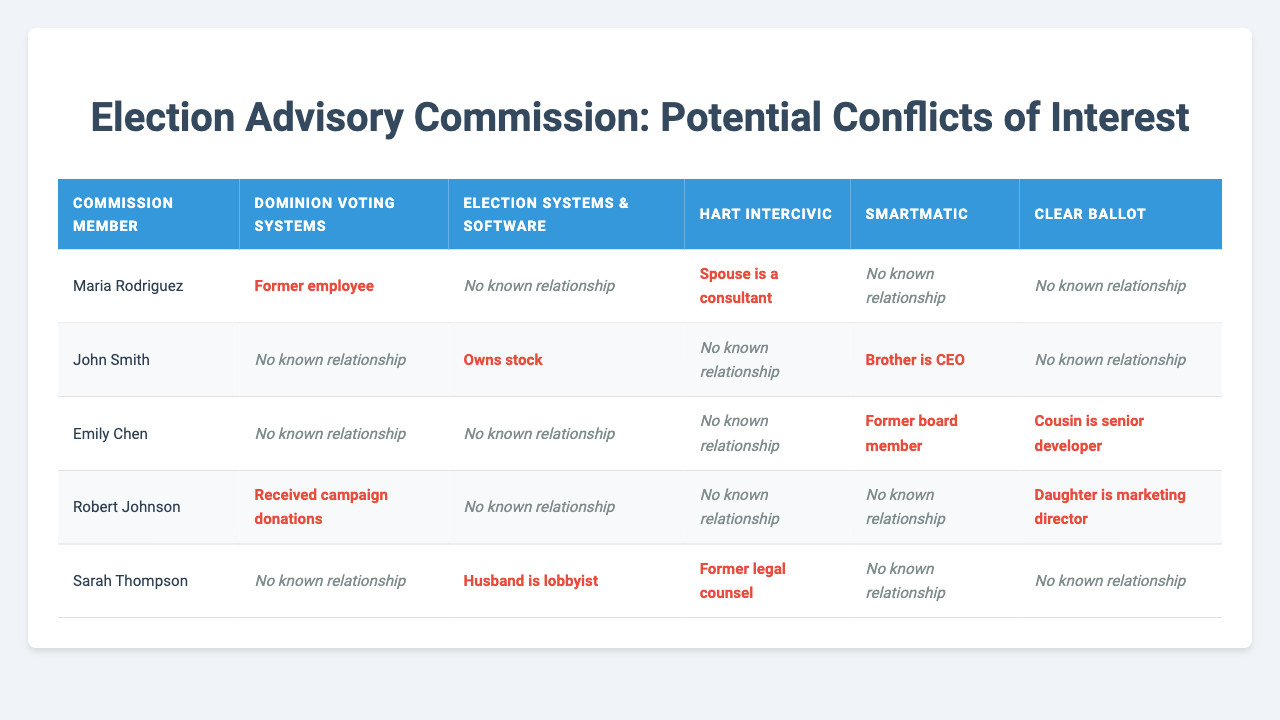What is the relationship of Maria Rodriguez with Dominion Voting Systems? The table shows that Maria Rodriguez has a relationship labeled "Former employee" with Dominion Voting Systems.
Answer: Former employee How many commission members have a relationship with Smartmatic? Reviewing the table, it shows that John Smith, Emily Chen, and Robert Johnson have relationships with Smartmatic. Therefore, 3 members have a relationship with Smartmatic.
Answer: 3 Does Sarah Thompson have any familial relationships with any election technology vendors? The table shows that Sarah Thompson's relationship with the vendors includes "Former legal counsel" and "Husband is lobbyist," but no familial relationships are listed.
Answer: No Which vendor has the highest number of relationships reported? By analyzing the table, we can see the number of relationships: Dominion Voting Systems (3), Election Systems & Software (2), Hart InterCivic (2), Smartmatic (3), Clear Ballot (3). Since three vendors tie with three relationships each, there is no single "highest."
Answer: Dominion Voting Systems, Smartmatic, Clear Ballot What is the nature of the relationship between Robert Johnson and Dominion Voting Systems? The table indicates that Robert Johnson received campaign donations from Dominion Voting Systems, which categorizes his relationship as financial support rather than familial or employment.
Answer: Received campaign donations Is there any commission member who has multiple relationships with different vendors? Looking through the table, John Smith has relationships with Election Systems & Software and Smartmatic, while Robert Johnson has relationships with Dominion Voting Systems and Clear Ballot. Therefore, yes, both have multiple relationships.
Answer: Yes Who is Emily Chen's cousin and where does he or she work? The table specifies that Emily Chen has a cousin who is a senior developer at Clear Ballot. Thus, the cousin works at Clear Ballot.
Answer: Senior developer at Clear Ballot Which commission member works with a vendor through a spouse? According to the table, Maria Rodriguez has a relationship labeled "Spouse is a consultant" with Hart InterCivic, indicating her husband or wife has a consulting role there.
Answer: Maria Rodriguez How many commission members have a direct familial relationship with vendors? Upon examining the table, only Emily Chen has a familial relationship (Cousin with a senior developer at Clear Ballot) and Robert Johnson also has familial ties (Daughter is marketing director at Clear Ballot). So there are 2 members with familial relationships.
Answer: 2 What type of relationship does John Smith have with Smartmatic? The table shows that John Smith's relationship with Smartmatic is noted as "Brother is CEO," indicating a familial relationship through his brother.
Answer: Brother is CEO Which election technology vendor has the least reported relationships with commission members? Analyzing the table, Smartmatic, Hart InterCivic, and Clear Ballot each have two members associated with them, while Election Systems & Software only has one member linked. Thus, Election Systems & Software has the least reported relationships.
Answer: Election Systems & Software 